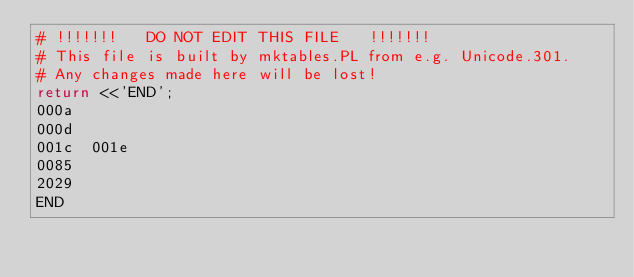<code> <loc_0><loc_0><loc_500><loc_500><_Perl_># !!!!!!!   DO NOT EDIT THIS FILE   !!!!!!! 
# This file is built by mktables.PL from e.g. Unicode.301.
# Any changes made here will be lost!
return <<'END';
000a	
000d	
001c	001e
0085	
2029	
END
</code> 